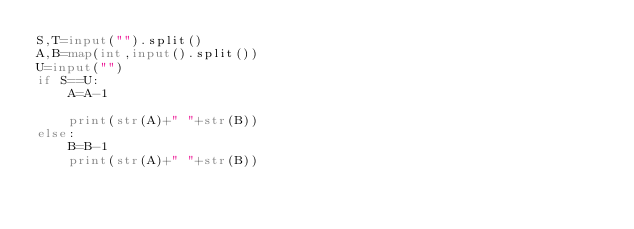<code> <loc_0><loc_0><loc_500><loc_500><_Python_>S,T=input("").split()
A,B=map(int,input().split())
U=input("")
if S==U:
    A=A-1
    
    print(str(A)+" "+str(B))
else:
    B=B-1
    print(str(A)+" "+str(B))</code> 